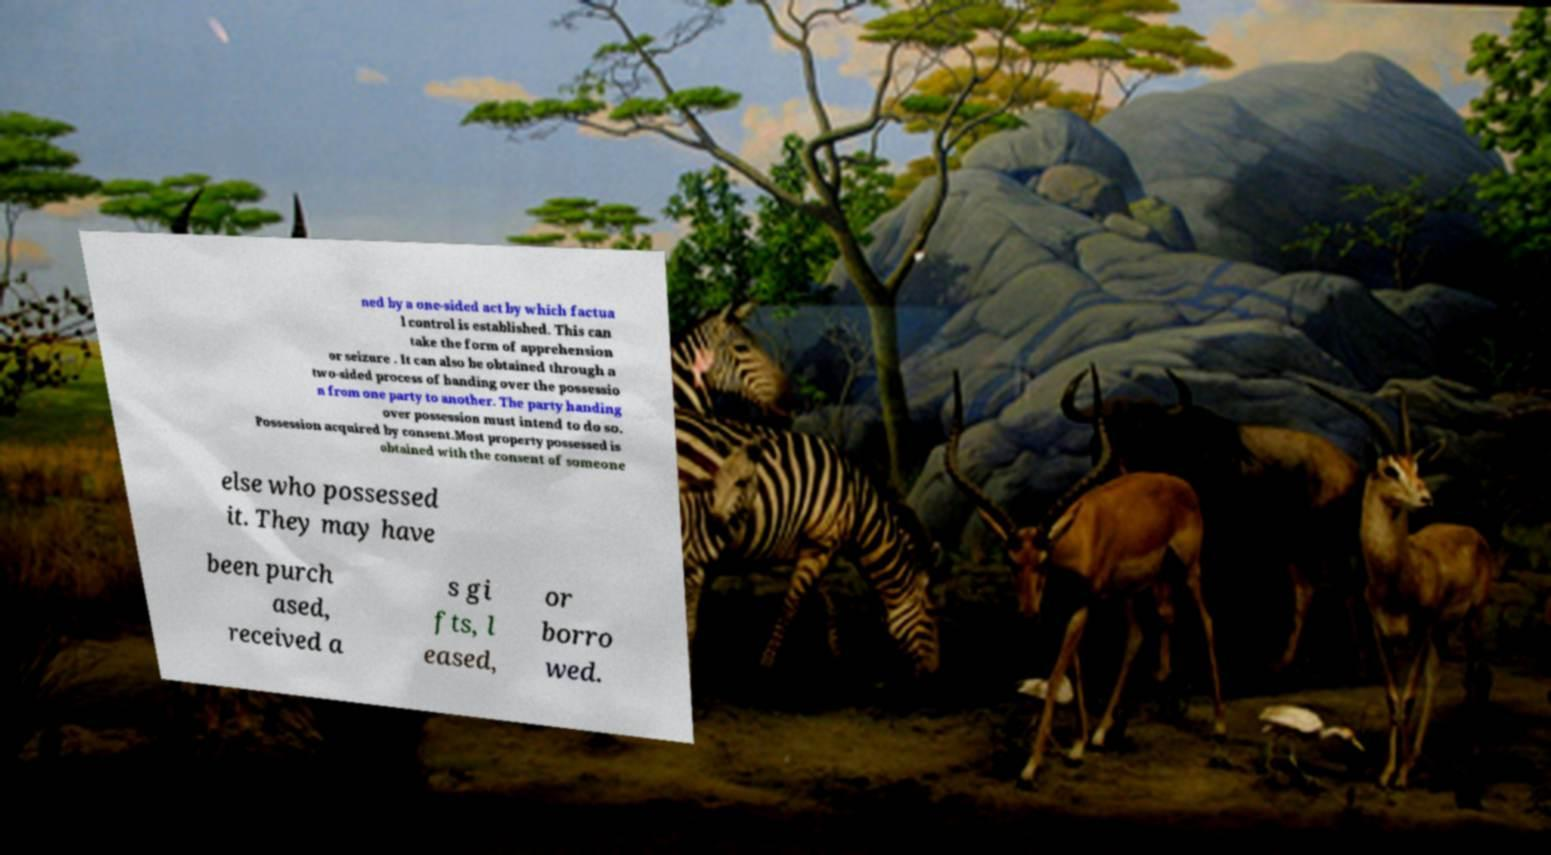For documentation purposes, I need the text within this image transcribed. Could you provide that? ned by a one-sided act by which factua l control is established. This can take the form of apprehension or seizure . It can also be obtained through a two-sided process of handing over the possessio n from one party to another. The party handing over possession must intend to do so. Possession acquired by consent.Most property possessed is obtained with the consent of someone else who possessed it. They may have been purch ased, received a s gi fts, l eased, or borro wed. 